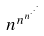<formula> <loc_0><loc_0><loc_500><loc_500>n ^ { n ^ { n ^ { \cdot ^ { \cdot ^ { \cdot } } } } }</formula> 